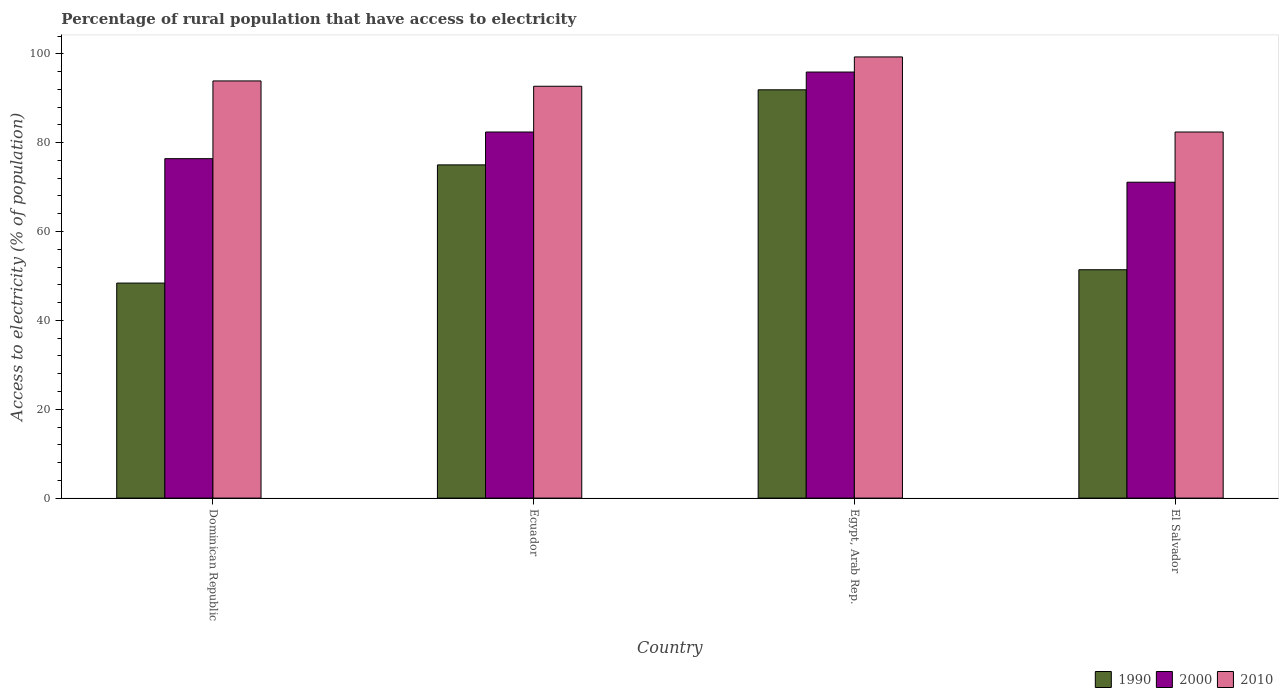How many different coloured bars are there?
Provide a short and direct response. 3. Are the number of bars per tick equal to the number of legend labels?
Your response must be concise. Yes. How many bars are there on the 3rd tick from the left?
Your answer should be compact. 3. How many bars are there on the 1st tick from the right?
Your answer should be compact. 3. What is the label of the 3rd group of bars from the left?
Your answer should be compact. Egypt, Arab Rep. In how many cases, is the number of bars for a given country not equal to the number of legend labels?
Provide a short and direct response. 0. What is the percentage of rural population that have access to electricity in 2010 in Ecuador?
Give a very brief answer. 92.7. Across all countries, what is the maximum percentage of rural population that have access to electricity in 2010?
Make the answer very short. 99.3. Across all countries, what is the minimum percentage of rural population that have access to electricity in 2010?
Ensure brevity in your answer.  82.4. In which country was the percentage of rural population that have access to electricity in 2000 maximum?
Your answer should be compact. Egypt, Arab Rep. In which country was the percentage of rural population that have access to electricity in 2000 minimum?
Provide a short and direct response. El Salvador. What is the total percentage of rural population that have access to electricity in 1990 in the graph?
Keep it short and to the point. 266.7. What is the difference between the percentage of rural population that have access to electricity in 2010 in Ecuador and that in Egypt, Arab Rep.?
Provide a succinct answer. -6.6. What is the difference between the percentage of rural population that have access to electricity in 2000 in El Salvador and the percentage of rural population that have access to electricity in 1990 in Egypt, Arab Rep.?
Your response must be concise. -20.8. What is the average percentage of rural population that have access to electricity in 2000 per country?
Your response must be concise. 81.45. What is the difference between the percentage of rural population that have access to electricity of/in 1990 and percentage of rural population that have access to electricity of/in 2000 in Ecuador?
Offer a very short reply. -7.4. In how many countries, is the percentage of rural population that have access to electricity in 1990 greater than 68 %?
Give a very brief answer. 2. What is the ratio of the percentage of rural population that have access to electricity in 2000 in Dominican Republic to that in Ecuador?
Offer a terse response. 0.93. Is the percentage of rural population that have access to electricity in 2010 in Ecuador less than that in El Salvador?
Provide a succinct answer. No. What is the difference between the highest and the second highest percentage of rural population that have access to electricity in 2000?
Ensure brevity in your answer.  6. What is the difference between the highest and the lowest percentage of rural population that have access to electricity in 1990?
Provide a short and direct response. 43.5. Is the sum of the percentage of rural population that have access to electricity in 1990 in Dominican Republic and El Salvador greater than the maximum percentage of rural population that have access to electricity in 2000 across all countries?
Your response must be concise. Yes. What does the 2nd bar from the right in Ecuador represents?
Your response must be concise. 2000. How many bars are there?
Your response must be concise. 12. What is the difference between two consecutive major ticks on the Y-axis?
Your answer should be very brief. 20. Are the values on the major ticks of Y-axis written in scientific E-notation?
Keep it short and to the point. No. How are the legend labels stacked?
Ensure brevity in your answer.  Horizontal. What is the title of the graph?
Provide a short and direct response. Percentage of rural population that have access to electricity. What is the label or title of the X-axis?
Provide a succinct answer. Country. What is the label or title of the Y-axis?
Provide a succinct answer. Access to electricity (% of population). What is the Access to electricity (% of population) in 1990 in Dominican Republic?
Offer a terse response. 48.4. What is the Access to electricity (% of population) in 2000 in Dominican Republic?
Your response must be concise. 76.4. What is the Access to electricity (% of population) in 2010 in Dominican Republic?
Make the answer very short. 93.9. What is the Access to electricity (% of population) of 2000 in Ecuador?
Keep it short and to the point. 82.4. What is the Access to electricity (% of population) of 2010 in Ecuador?
Your answer should be very brief. 92.7. What is the Access to electricity (% of population) in 1990 in Egypt, Arab Rep.?
Give a very brief answer. 91.9. What is the Access to electricity (% of population) of 2000 in Egypt, Arab Rep.?
Your response must be concise. 95.9. What is the Access to electricity (% of population) of 2010 in Egypt, Arab Rep.?
Your answer should be very brief. 99.3. What is the Access to electricity (% of population) in 1990 in El Salvador?
Keep it short and to the point. 51.4. What is the Access to electricity (% of population) in 2000 in El Salvador?
Your answer should be compact. 71.1. What is the Access to electricity (% of population) in 2010 in El Salvador?
Provide a succinct answer. 82.4. Across all countries, what is the maximum Access to electricity (% of population) of 1990?
Offer a very short reply. 91.9. Across all countries, what is the maximum Access to electricity (% of population) in 2000?
Give a very brief answer. 95.9. Across all countries, what is the maximum Access to electricity (% of population) of 2010?
Your response must be concise. 99.3. Across all countries, what is the minimum Access to electricity (% of population) in 1990?
Make the answer very short. 48.4. Across all countries, what is the minimum Access to electricity (% of population) in 2000?
Provide a succinct answer. 71.1. Across all countries, what is the minimum Access to electricity (% of population) of 2010?
Your response must be concise. 82.4. What is the total Access to electricity (% of population) of 1990 in the graph?
Offer a very short reply. 266.7. What is the total Access to electricity (% of population) in 2000 in the graph?
Offer a very short reply. 325.8. What is the total Access to electricity (% of population) of 2010 in the graph?
Your answer should be compact. 368.3. What is the difference between the Access to electricity (% of population) in 1990 in Dominican Republic and that in Ecuador?
Your answer should be compact. -26.6. What is the difference between the Access to electricity (% of population) of 2000 in Dominican Republic and that in Ecuador?
Give a very brief answer. -6. What is the difference between the Access to electricity (% of population) in 2010 in Dominican Republic and that in Ecuador?
Ensure brevity in your answer.  1.2. What is the difference between the Access to electricity (% of population) of 1990 in Dominican Republic and that in Egypt, Arab Rep.?
Keep it short and to the point. -43.5. What is the difference between the Access to electricity (% of population) of 2000 in Dominican Republic and that in Egypt, Arab Rep.?
Your answer should be compact. -19.5. What is the difference between the Access to electricity (% of population) of 2010 in Dominican Republic and that in Egypt, Arab Rep.?
Provide a short and direct response. -5.4. What is the difference between the Access to electricity (% of population) of 2010 in Dominican Republic and that in El Salvador?
Your answer should be very brief. 11.5. What is the difference between the Access to electricity (% of population) of 1990 in Ecuador and that in Egypt, Arab Rep.?
Your answer should be compact. -16.9. What is the difference between the Access to electricity (% of population) of 1990 in Ecuador and that in El Salvador?
Keep it short and to the point. 23.6. What is the difference between the Access to electricity (% of population) in 1990 in Egypt, Arab Rep. and that in El Salvador?
Your answer should be compact. 40.5. What is the difference between the Access to electricity (% of population) of 2000 in Egypt, Arab Rep. and that in El Salvador?
Give a very brief answer. 24.8. What is the difference between the Access to electricity (% of population) of 2010 in Egypt, Arab Rep. and that in El Salvador?
Your answer should be compact. 16.9. What is the difference between the Access to electricity (% of population) in 1990 in Dominican Republic and the Access to electricity (% of population) in 2000 in Ecuador?
Provide a succinct answer. -34. What is the difference between the Access to electricity (% of population) in 1990 in Dominican Republic and the Access to electricity (% of population) in 2010 in Ecuador?
Give a very brief answer. -44.3. What is the difference between the Access to electricity (% of population) in 2000 in Dominican Republic and the Access to electricity (% of population) in 2010 in Ecuador?
Provide a short and direct response. -16.3. What is the difference between the Access to electricity (% of population) of 1990 in Dominican Republic and the Access to electricity (% of population) of 2000 in Egypt, Arab Rep.?
Give a very brief answer. -47.5. What is the difference between the Access to electricity (% of population) in 1990 in Dominican Republic and the Access to electricity (% of population) in 2010 in Egypt, Arab Rep.?
Offer a very short reply. -50.9. What is the difference between the Access to electricity (% of population) in 2000 in Dominican Republic and the Access to electricity (% of population) in 2010 in Egypt, Arab Rep.?
Provide a short and direct response. -22.9. What is the difference between the Access to electricity (% of population) in 1990 in Dominican Republic and the Access to electricity (% of population) in 2000 in El Salvador?
Provide a succinct answer. -22.7. What is the difference between the Access to electricity (% of population) of 1990 in Dominican Republic and the Access to electricity (% of population) of 2010 in El Salvador?
Keep it short and to the point. -34. What is the difference between the Access to electricity (% of population) of 1990 in Ecuador and the Access to electricity (% of population) of 2000 in Egypt, Arab Rep.?
Your answer should be very brief. -20.9. What is the difference between the Access to electricity (% of population) of 1990 in Ecuador and the Access to electricity (% of population) of 2010 in Egypt, Arab Rep.?
Offer a very short reply. -24.3. What is the difference between the Access to electricity (% of population) in 2000 in Ecuador and the Access to electricity (% of population) in 2010 in Egypt, Arab Rep.?
Your response must be concise. -16.9. What is the difference between the Access to electricity (% of population) in 1990 in Ecuador and the Access to electricity (% of population) in 2000 in El Salvador?
Give a very brief answer. 3.9. What is the difference between the Access to electricity (% of population) in 2000 in Ecuador and the Access to electricity (% of population) in 2010 in El Salvador?
Give a very brief answer. 0. What is the difference between the Access to electricity (% of population) of 1990 in Egypt, Arab Rep. and the Access to electricity (% of population) of 2000 in El Salvador?
Ensure brevity in your answer.  20.8. What is the difference between the Access to electricity (% of population) of 1990 in Egypt, Arab Rep. and the Access to electricity (% of population) of 2010 in El Salvador?
Keep it short and to the point. 9.5. What is the average Access to electricity (% of population) in 1990 per country?
Keep it short and to the point. 66.67. What is the average Access to electricity (% of population) of 2000 per country?
Provide a short and direct response. 81.45. What is the average Access to electricity (% of population) in 2010 per country?
Your response must be concise. 92.08. What is the difference between the Access to electricity (% of population) in 1990 and Access to electricity (% of population) in 2010 in Dominican Republic?
Your response must be concise. -45.5. What is the difference between the Access to electricity (% of population) of 2000 and Access to electricity (% of population) of 2010 in Dominican Republic?
Provide a short and direct response. -17.5. What is the difference between the Access to electricity (% of population) in 1990 and Access to electricity (% of population) in 2000 in Ecuador?
Provide a succinct answer. -7.4. What is the difference between the Access to electricity (% of population) in 1990 and Access to electricity (% of population) in 2010 in Ecuador?
Give a very brief answer. -17.7. What is the difference between the Access to electricity (% of population) of 1990 and Access to electricity (% of population) of 2000 in Egypt, Arab Rep.?
Give a very brief answer. -4. What is the difference between the Access to electricity (% of population) in 1990 and Access to electricity (% of population) in 2010 in Egypt, Arab Rep.?
Offer a terse response. -7.4. What is the difference between the Access to electricity (% of population) in 1990 and Access to electricity (% of population) in 2000 in El Salvador?
Your response must be concise. -19.7. What is the difference between the Access to electricity (% of population) of 1990 and Access to electricity (% of population) of 2010 in El Salvador?
Your answer should be very brief. -31. What is the difference between the Access to electricity (% of population) of 2000 and Access to electricity (% of population) of 2010 in El Salvador?
Give a very brief answer. -11.3. What is the ratio of the Access to electricity (% of population) in 1990 in Dominican Republic to that in Ecuador?
Ensure brevity in your answer.  0.65. What is the ratio of the Access to electricity (% of population) of 2000 in Dominican Republic to that in Ecuador?
Offer a very short reply. 0.93. What is the ratio of the Access to electricity (% of population) in 2010 in Dominican Republic to that in Ecuador?
Ensure brevity in your answer.  1.01. What is the ratio of the Access to electricity (% of population) of 1990 in Dominican Republic to that in Egypt, Arab Rep.?
Offer a terse response. 0.53. What is the ratio of the Access to electricity (% of population) in 2000 in Dominican Republic to that in Egypt, Arab Rep.?
Your answer should be compact. 0.8. What is the ratio of the Access to electricity (% of population) in 2010 in Dominican Republic to that in Egypt, Arab Rep.?
Offer a very short reply. 0.95. What is the ratio of the Access to electricity (% of population) of 1990 in Dominican Republic to that in El Salvador?
Offer a terse response. 0.94. What is the ratio of the Access to electricity (% of population) of 2000 in Dominican Republic to that in El Salvador?
Provide a succinct answer. 1.07. What is the ratio of the Access to electricity (% of population) of 2010 in Dominican Republic to that in El Salvador?
Provide a short and direct response. 1.14. What is the ratio of the Access to electricity (% of population) of 1990 in Ecuador to that in Egypt, Arab Rep.?
Give a very brief answer. 0.82. What is the ratio of the Access to electricity (% of population) in 2000 in Ecuador to that in Egypt, Arab Rep.?
Provide a succinct answer. 0.86. What is the ratio of the Access to electricity (% of population) in 2010 in Ecuador to that in Egypt, Arab Rep.?
Offer a very short reply. 0.93. What is the ratio of the Access to electricity (% of population) of 1990 in Ecuador to that in El Salvador?
Keep it short and to the point. 1.46. What is the ratio of the Access to electricity (% of population) of 2000 in Ecuador to that in El Salvador?
Offer a terse response. 1.16. What is the ratio of the Access to electricity (% of population) of 1990 in Egypt, Arab Rep. to that in El Salvador?
Your response must be concise. 1.79. What is the ratio of the Access to electricity (% of population) in 2000 in Egypt, Arab Rep. to that in El Salvador?
Your answer should be compact. 1.35. What is the ratio of the Access to electricity (% of population) of 2010 in Egypt, Arab Rep. to that in El Salvador?
Provide a succinct answer. 1.21. What is the difference between the highest and the second highest Access to electricity (% of population) in 1990?
Make the answer very short. 16.9. What is the difference between the highest and the second highest Access to electricity (% of population) of 2000?
Keep it short and to the point. 13.5. What is the difference between the highest and the lowest Access to electricity (% of population) in 1990?
Make the answer very short. 43.5. What is the difference between the highest and the lowest Access to electricity (% of population) of 2000?
Give a very brief answer. 24.8. What is the difference between the highest and the lowest Access to electricity (% of population) in 2010?
Your response must be concise. 16.9. 